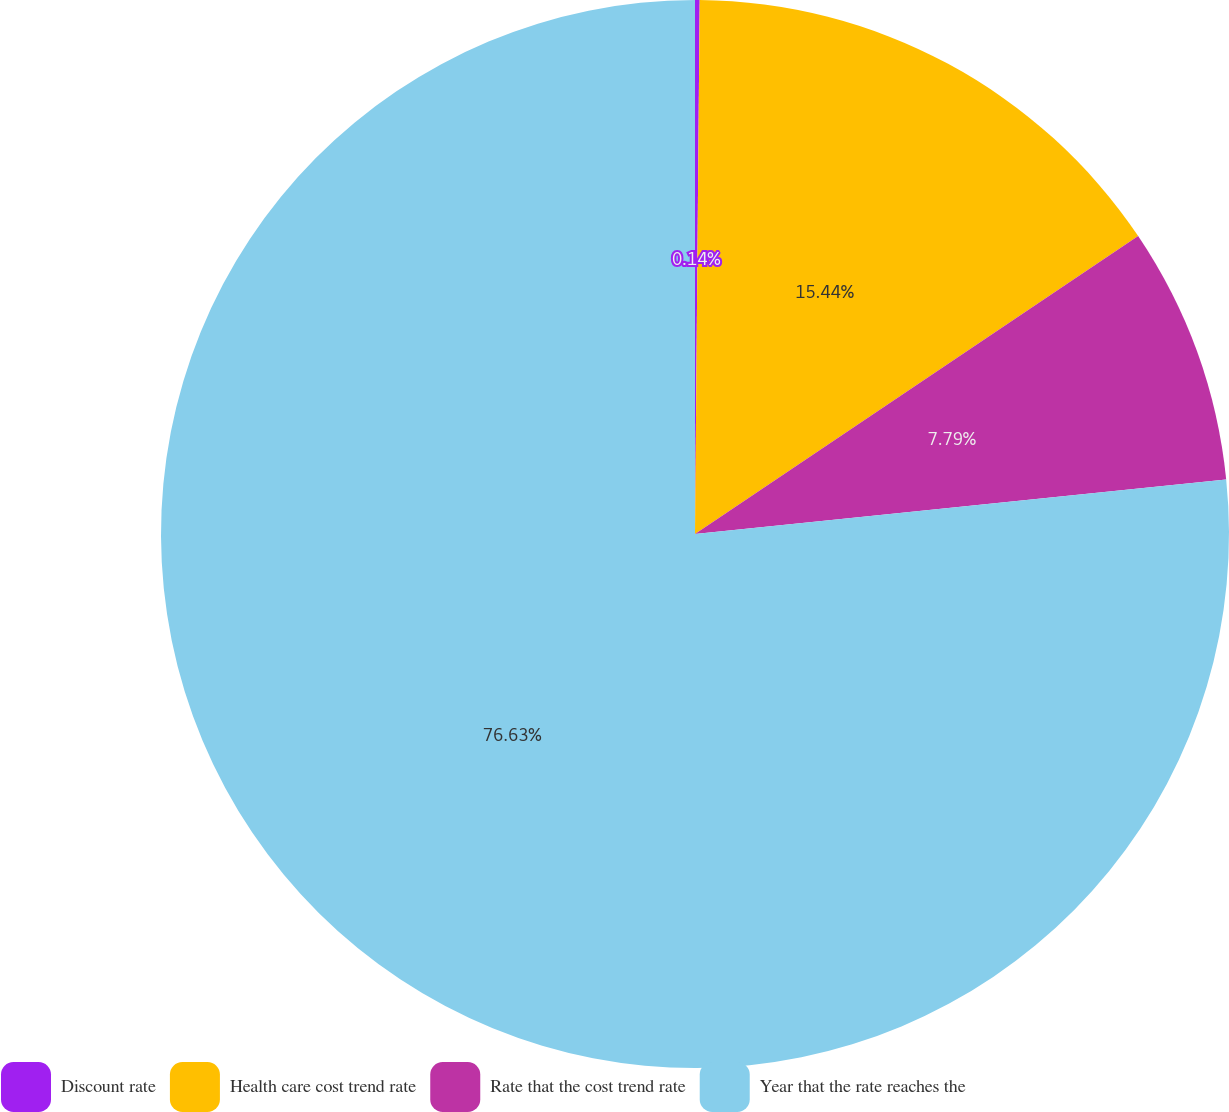Convert chart. <chart><loc_0><loc_0><loc_500><loc_500><pie_chart><fcel>Discount rate<fcel>Health care cost trend rate<fcel>Rate that the cost trend rate<fcel>Year that the rate reaches the<nl><fcel>0.14%<fcel>15.44%<fcel>7.79%<fcel>76.63%<nl></chart> 